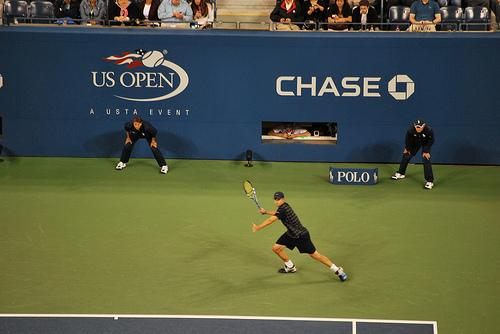Can you provide a brief description of the tennis player's outfit? The tennis player is wearing a dark cap, striped shirt, dark shorts, and white socks. What activity is the main person in the photo participating in? The main person is playing tennis. What color is the tennis racket and what color scheme does it follow? The tennis racket is a combination of blue, white, and black colors. Briefly describe the appearance of the tennis court and its surroundings in the image. There is a white line on the court, and a blue wall next to it with white letters. Provide a brief analysis of the tennis player's body position in the match. The tennis player has both arms lifted, and is holding a racket in a crouched posture. How many people are actively involved in the tennis match? At least two people are actively involved in the tennis match. Divide the image into regions and label each region with the corresponding object or area it represents. tennis court, tennis players, blue wall, white letters List the emotions or sentiments that can be perceived from this image. Excitement, competitiveness, focus Describe the interaction between the tennis players and the person watching through the window. The person watching seems focused on the tennis players' match, while the players are engaged in the competition. Identify any unusual features or discrepancies present in the image. No noticeable anomalies detected in the image. Evaluate the quality of the photograph, considering aspects such as sharpness, clarity, and lighting. Good quality, clear details, and well-lit Recognizing the image's text, note down what color the written letter is. White 